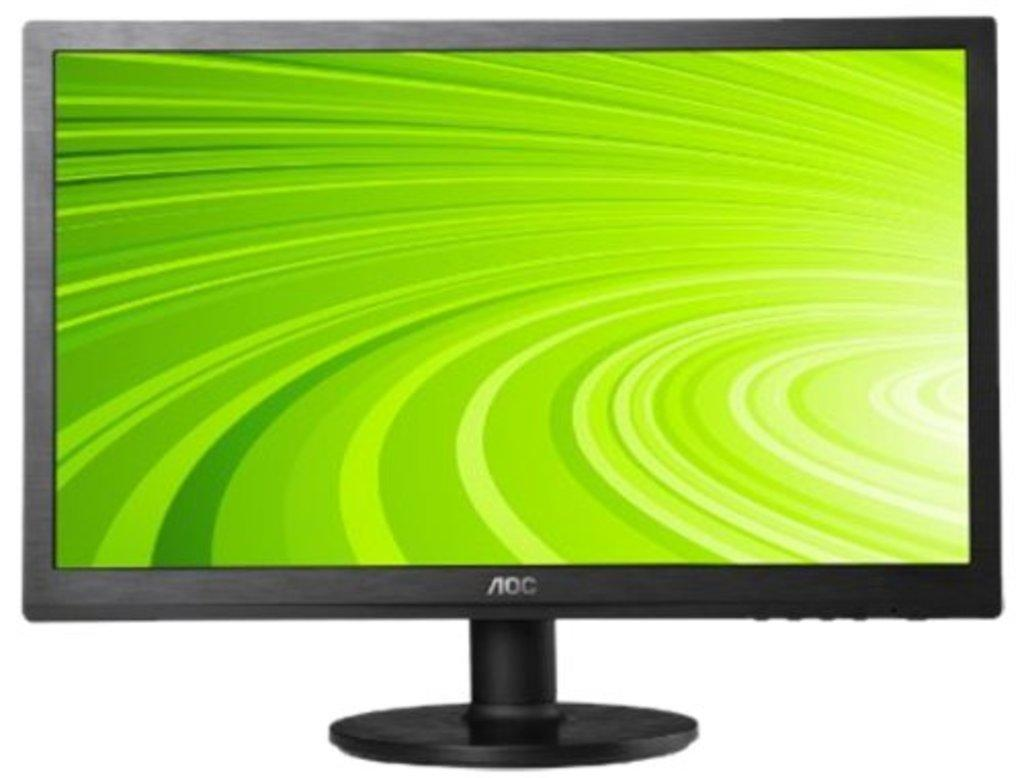<image>
Offer a succinct explanation of the picture presented. An AOC brand computer monitor with green swirlies on it. 